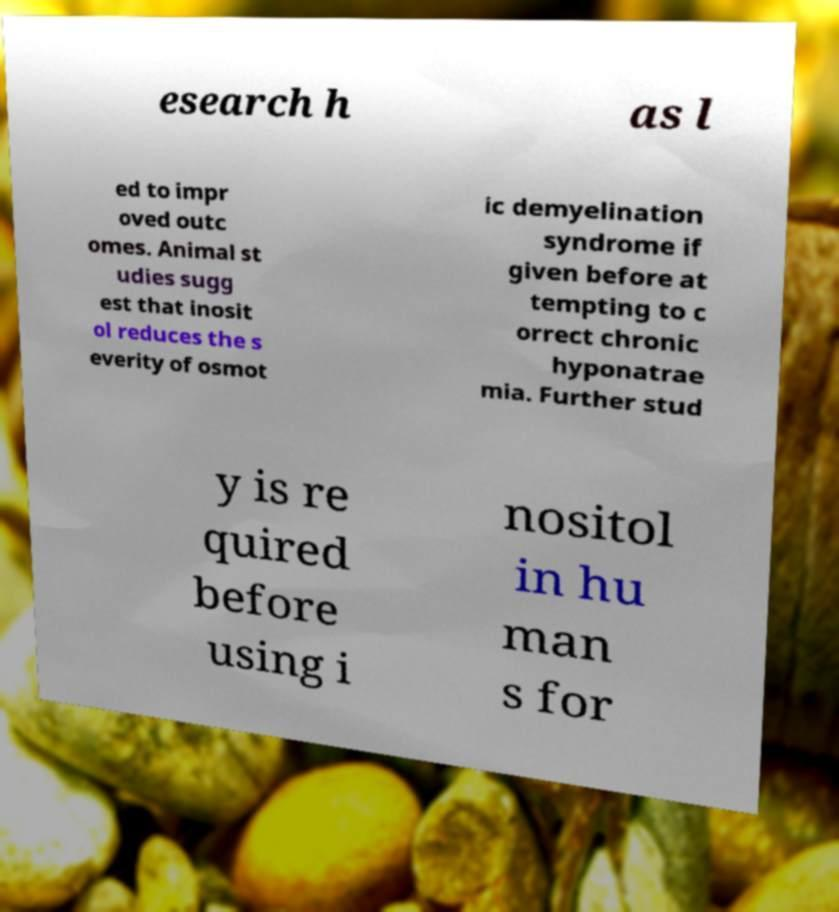I need the written content from this picture converted into text. Can you do that? esearch h as l ed to impr oved outc omes. Animal st udies sugg est that inosit ol reduces the s everity of osmot ic demyelination syndrome if given before at tempting to c orrect chronic hyponatrae mia. Further stud y is re quired before using i nositol in hu man s for 